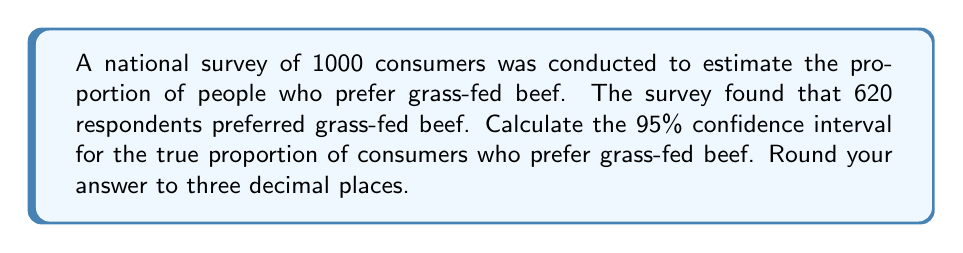Help me with this question. To calculate the confidence interval, we'll use the formula for a proportion:

$$ CI = \hat{p} \pm z\sqrt{\frac{\hat{p}(1-\hat{p})}{n}} $$

Where:
$\hat{p}$ = sample proportion
$z$ = z-score for desired confidence level (1.96 for 95% CI)
$n$ = sample size

Step 1: Calculate $\hat{p}$
$\hat{p} = \frac{620}{1000} = 0.62$

Step 2: Calculate the standard error
$SE = \sqrt{\frac{\hat{p}(1-\hat{p})}{n}} = \sqrt{\frac{0.62(1-0.62)}{1000}} = 0.015337$

Step 3: Calculate the margin of error
$ME = z \times SE = 1.96 \times 0.015337 = 0.030060$

Step 4: Calculate the confidence interval
Lower bound: $0.62 - 0.030060 = 0.589940$
Upper bound: $0.62 + 0.030060 = 0.650060$

Step 5: Round to three decimal places
Lower bound: 0.590
Upper bound: 0.650
Answer: (0.590, 0.650) 